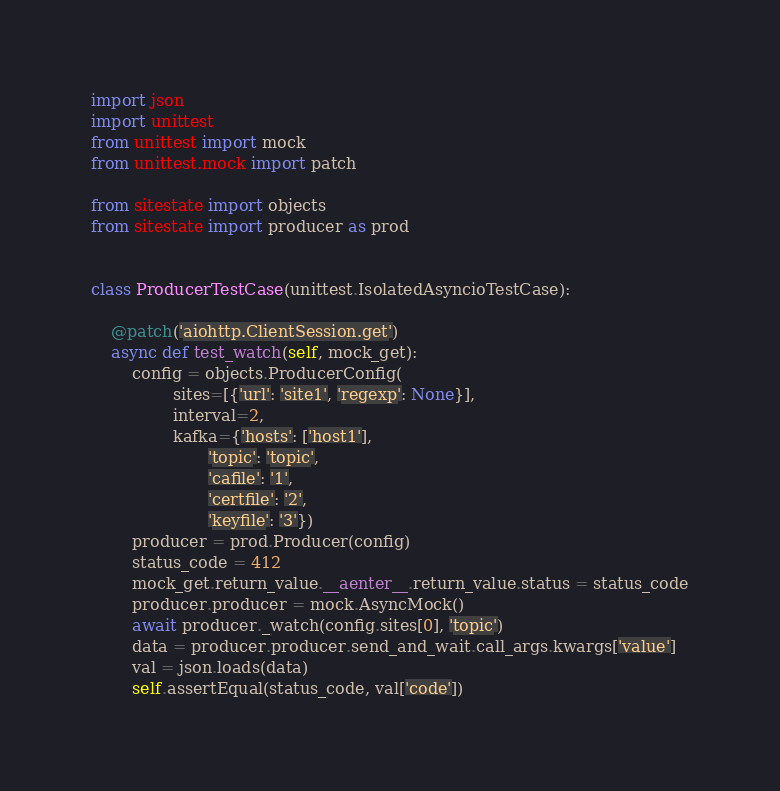<code> <loc_0><loc_0><loc_500><loc_500><_Python_>import json
import unittest
from unittest import mock
from unittest.mock import patch

from sitestate import objects
from sitestate import producer as prod


class ProducerTestCase(unittest.IsolatedAsyncioTestCase):

    @patch('aiohttp.ClientSession.get')
    async def test_watch(self, mock_get):
        config = objects.ProducerConfig(
                sites=[{'url': 'site1', 'regexp': None}],
                interval=2,
                kafka={'hosts': ['host1'],
                       'topic': 'topic',
                       'cafile': '1',
                       'certfile': '2',
                       'keyfile': '3'})
        producer = prod.Producer(config)
        status_code = 412
        mock_get.return_value.__aenter__.return_value.status = status_code
        producer.producer = mock.AsyncMock()
        await producer._watch(config.sites[0], 'topic')
        data = producer.producer.send_and_wait.call_args.kwargs['value']
        val = json.loads(data)
        self.assertEqual(status_code, val['code'])
</code> 